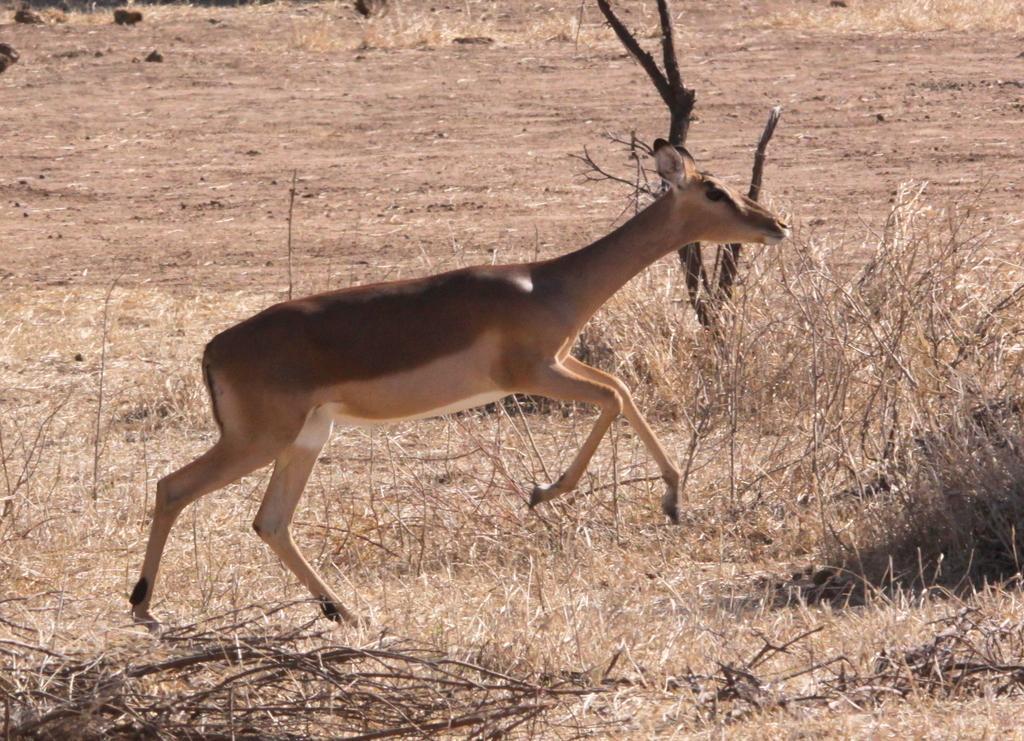Could you give a brief overview of what you see in this image? In this image there is a dry grass. There is mud. There are small stones. There is a deer. 